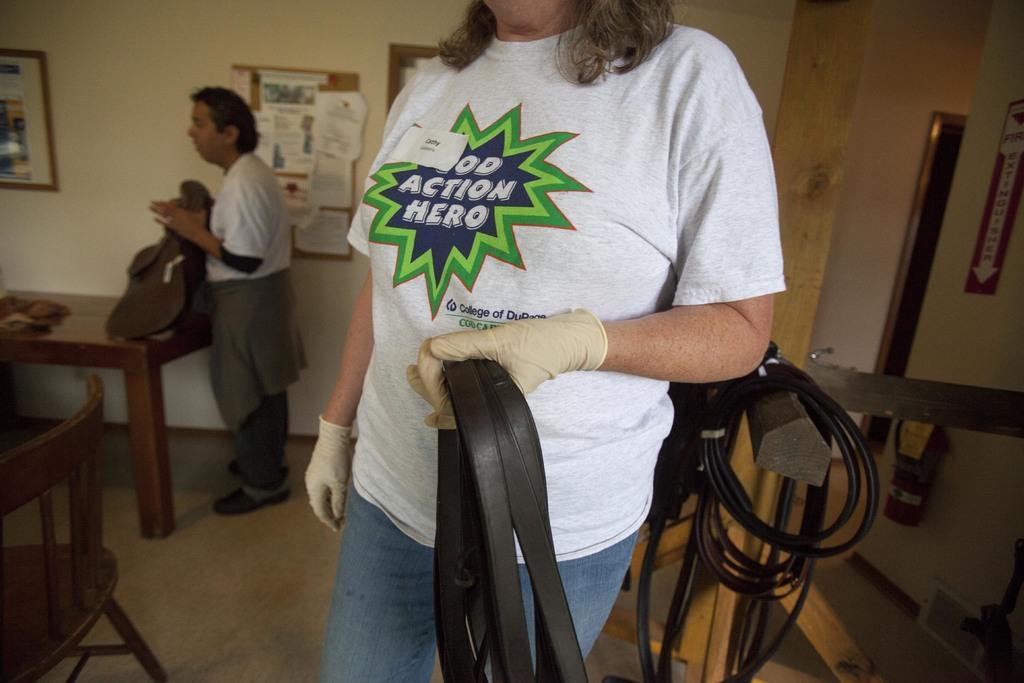How would you summarize this image in a sentence or two? In this picture there is a woman who is wearing a white t shirt. She is holding a belt and wearing a glove in her hand. At there is another man who is holding a bag. There is a chair. There is a board on which paper are there. There is a table. There is an arrow sign. 